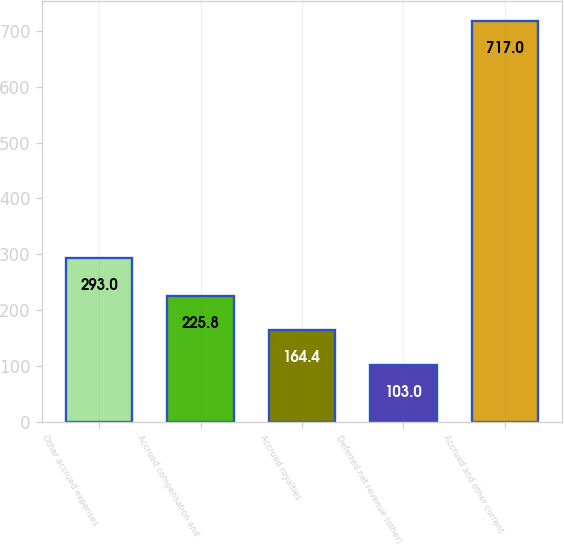<chart> <loc_0><loc_0><loc_500><loc_500><bar_chart><fcel>Other accrued expenses<fcel>Accrued compensation and<fcel>Accrued royalties<fcel>Deferred net revenue (other)<fcel>Accrued and other current<nl><fcel>293<fcel>225.8<fcel>164.4<fcel>103<fcel>717<nl></chart> 